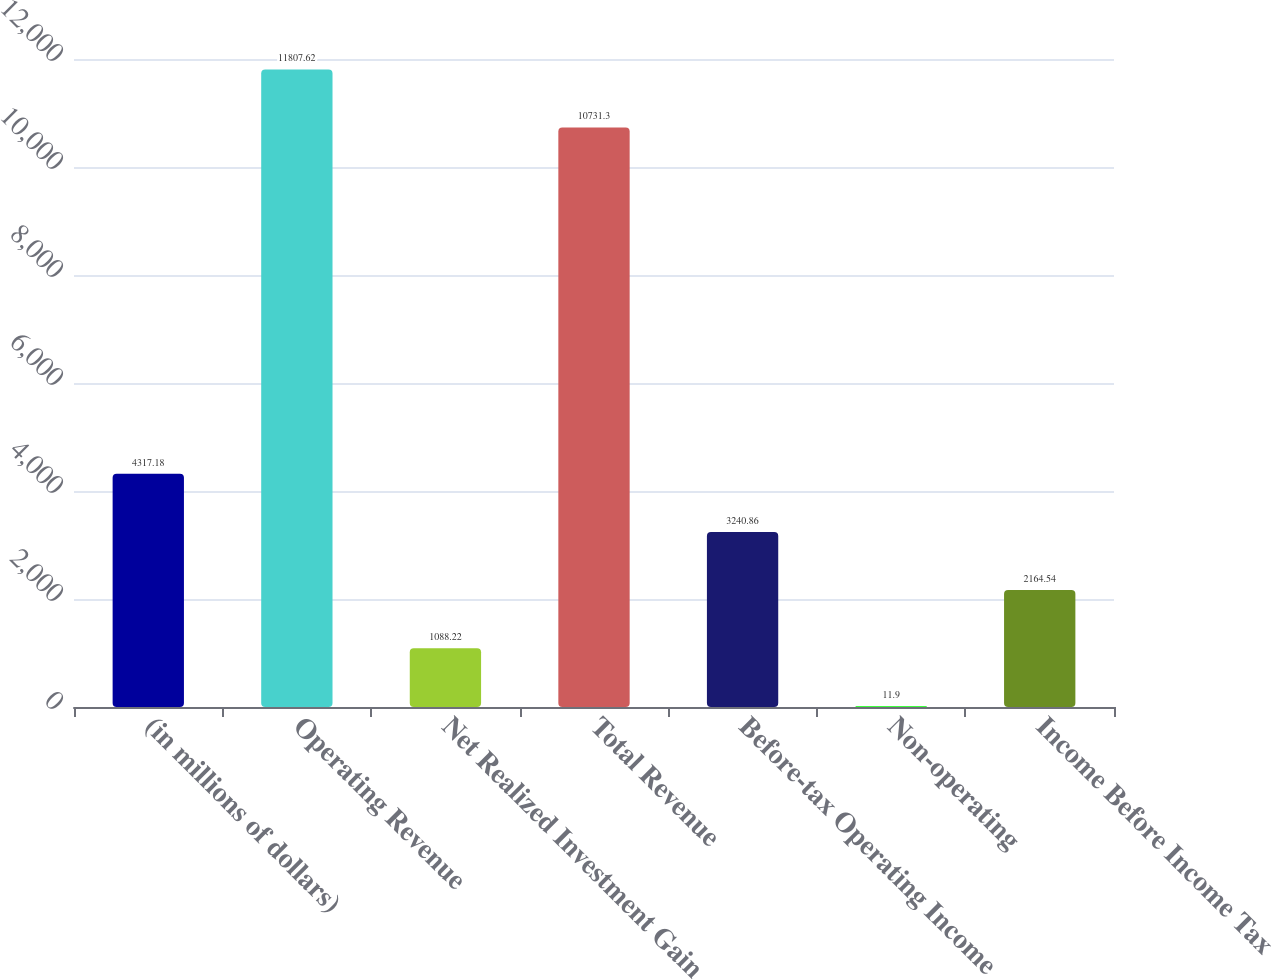Convert chart to OTSL. <chart><loc_0><loc_0><loc_500><loc_500><bar_chart><fcel>(in millions of dollars)<fcel>Operating Revenue<fcel>Net Realized Investment Gain<fcel>Total Revenue<fcel>Before-tax Operating Income<fcel>Non-operating<fcel>Income Before Income Tax<nl><fcel>4317.18<fcel>11807.6<fcel>1088.22<fcel>10731.3<fcel>3240.86<fcel>11.9<fcel>2164.54<nl></chart> 